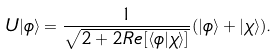Convert formula to latex. <formula><loc_0><loc_0><loc_500><loc_500>U | \phi \rangle = \frac { 1 } { \sqrt { 2 + 2 R e [ \langle \phi | \chi \rangle ] } } ( | \phi \rangle + | \chi \rangle ) .</formula> 